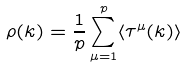<formula> <loc_0><loc_0><loc_500><loc_500>\rho ( k ) = \frac { 1 } { p } \sum _ { \mu = 1 } ^ { p } \langle \tau ^ { \mu } ( k ) \rangle</formula> 